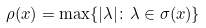<formula> <loc_0><loc_0><loc_500><loc_500>\rho ( x ) = \max \{ | \lambda | \colon \lambda \in \sigma ( x ) \}</formula> 